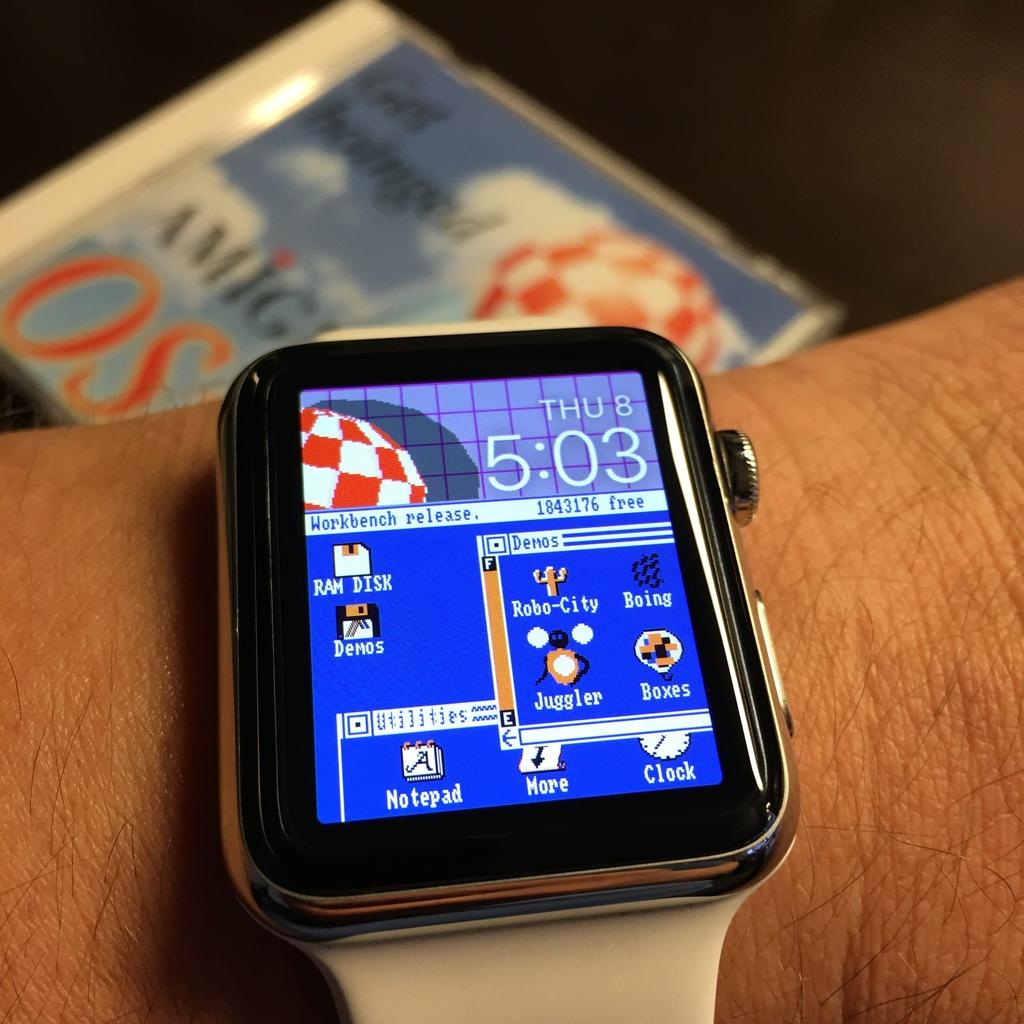What day of the week is on the watch?
Your response must be concise. Thursday. What time is it?
Your answer should be compact. 5:03. 